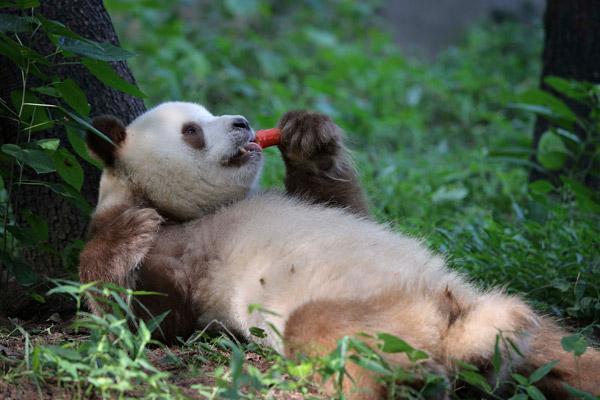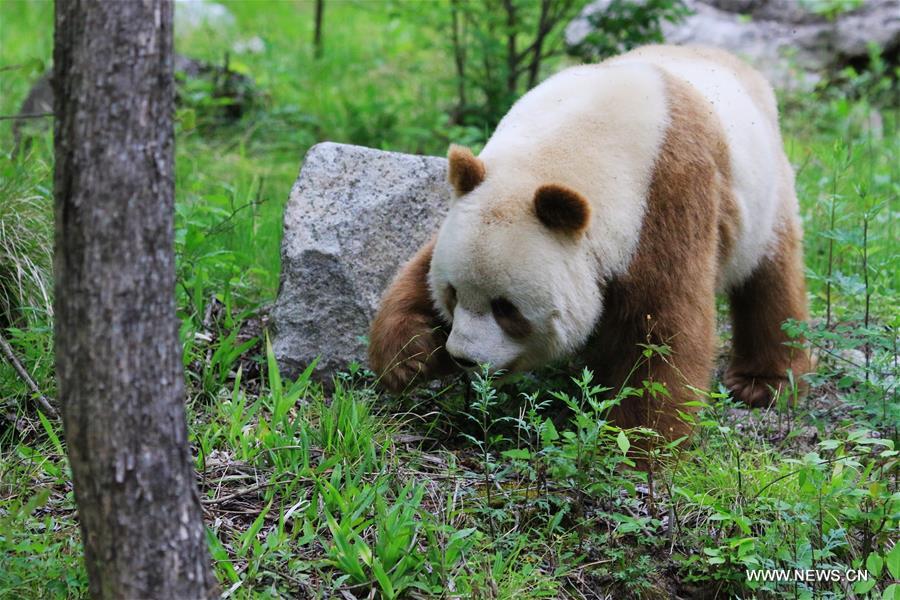The first image is the image on the left, the second image is the image on the right. For the images shown, is this caption "Right image shows a panda half sitting, half lying, with legs extended and back curled." true? Answer yes or no. No. The first image is the image on the left, the second image is the image on the right. For the images displayed, is the sentence "A panda is feeding itself." factually correct? Answer yes or no. Yes. 